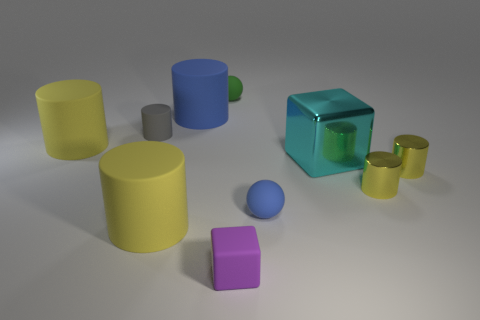The gray rubber thing has what shape?
Give a very brief answer. Cylinder. There is a tiny matte block; is its color the same as the matte sphere that is behind the blue cylinder?
Ensure brevity in your answer.  No. Are there fewer tiny green things that are in front of the cyan object than small gray objects in front of the tiny purple cube?
Your answer should be compact. No. There is a matte object that is right of the blue cylinder and behind the gray cylinder; what color is it?
Make the answer very short. Green. Does the purple cube have the same size as the green matte thing on the left side of the tiny blue object?
Give a very brief answer. Yes. There is a big yellow thing that is right of the small gray matte cylinder; what is its shape?
Offer a terse response. Cylinder. Are there any other things that have the same material as the purple thing?
Make the answer very short. Yes. Are there more big metallic blocks that are in front of the large metal thing than yellow rubber cylinders?
Your response must be concise. No. How many big objects are in front of the tiny sphere in front of the yellow cylinder behind the large cube?
Make the answer very short. 1. There is a blue thing behind the gray cylinder; is its size the same as the matte object that is behind the large blue thing?
Your answer should be very brief. No. 